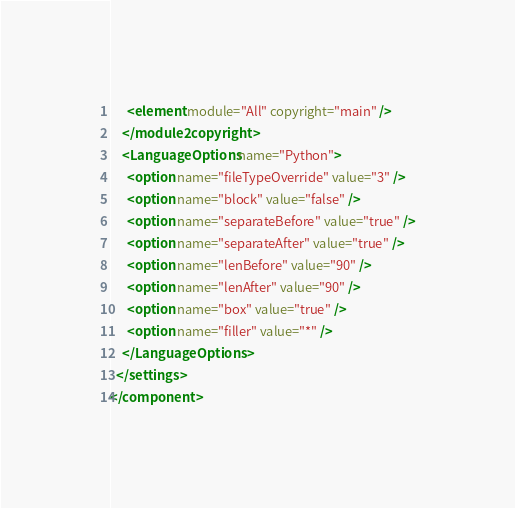Convert code to text. <code><loc_0><loc_0><loc_500><loc_500><_XML_>      <element module="All" copyright="main" />
    </module2copyright>
    <LanguageOptions name="Python">
      <option name="fileTypeOverride" value="3" />
      <option name="block" value="false" />
      <option name="separateBefore" value="true" />
      <option name="separateAfter" value="true" />
      <option name="lenBefore" value="90" />
      <option name="lenAfter" value="90" />
      <option name="box" value="true" />
      <option name="filler" value="*" />
    </LanguageOptions>
  </settings>
</component></code> 